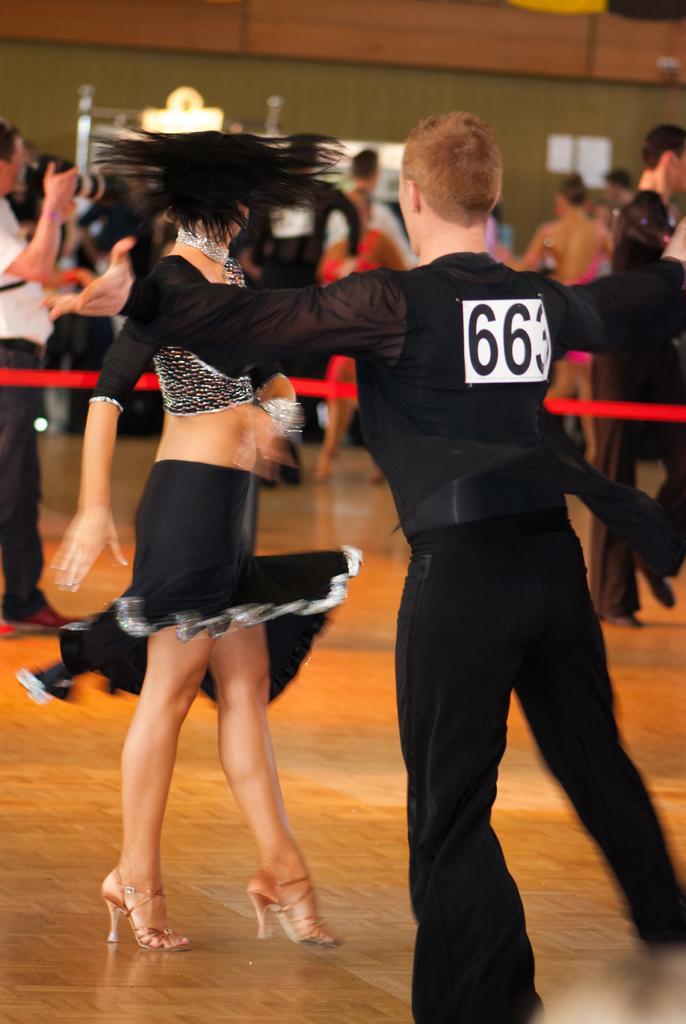Please provide a concise description of this image. In the image I can see a lady and a guy who are dancing and to the side there are some other people. 